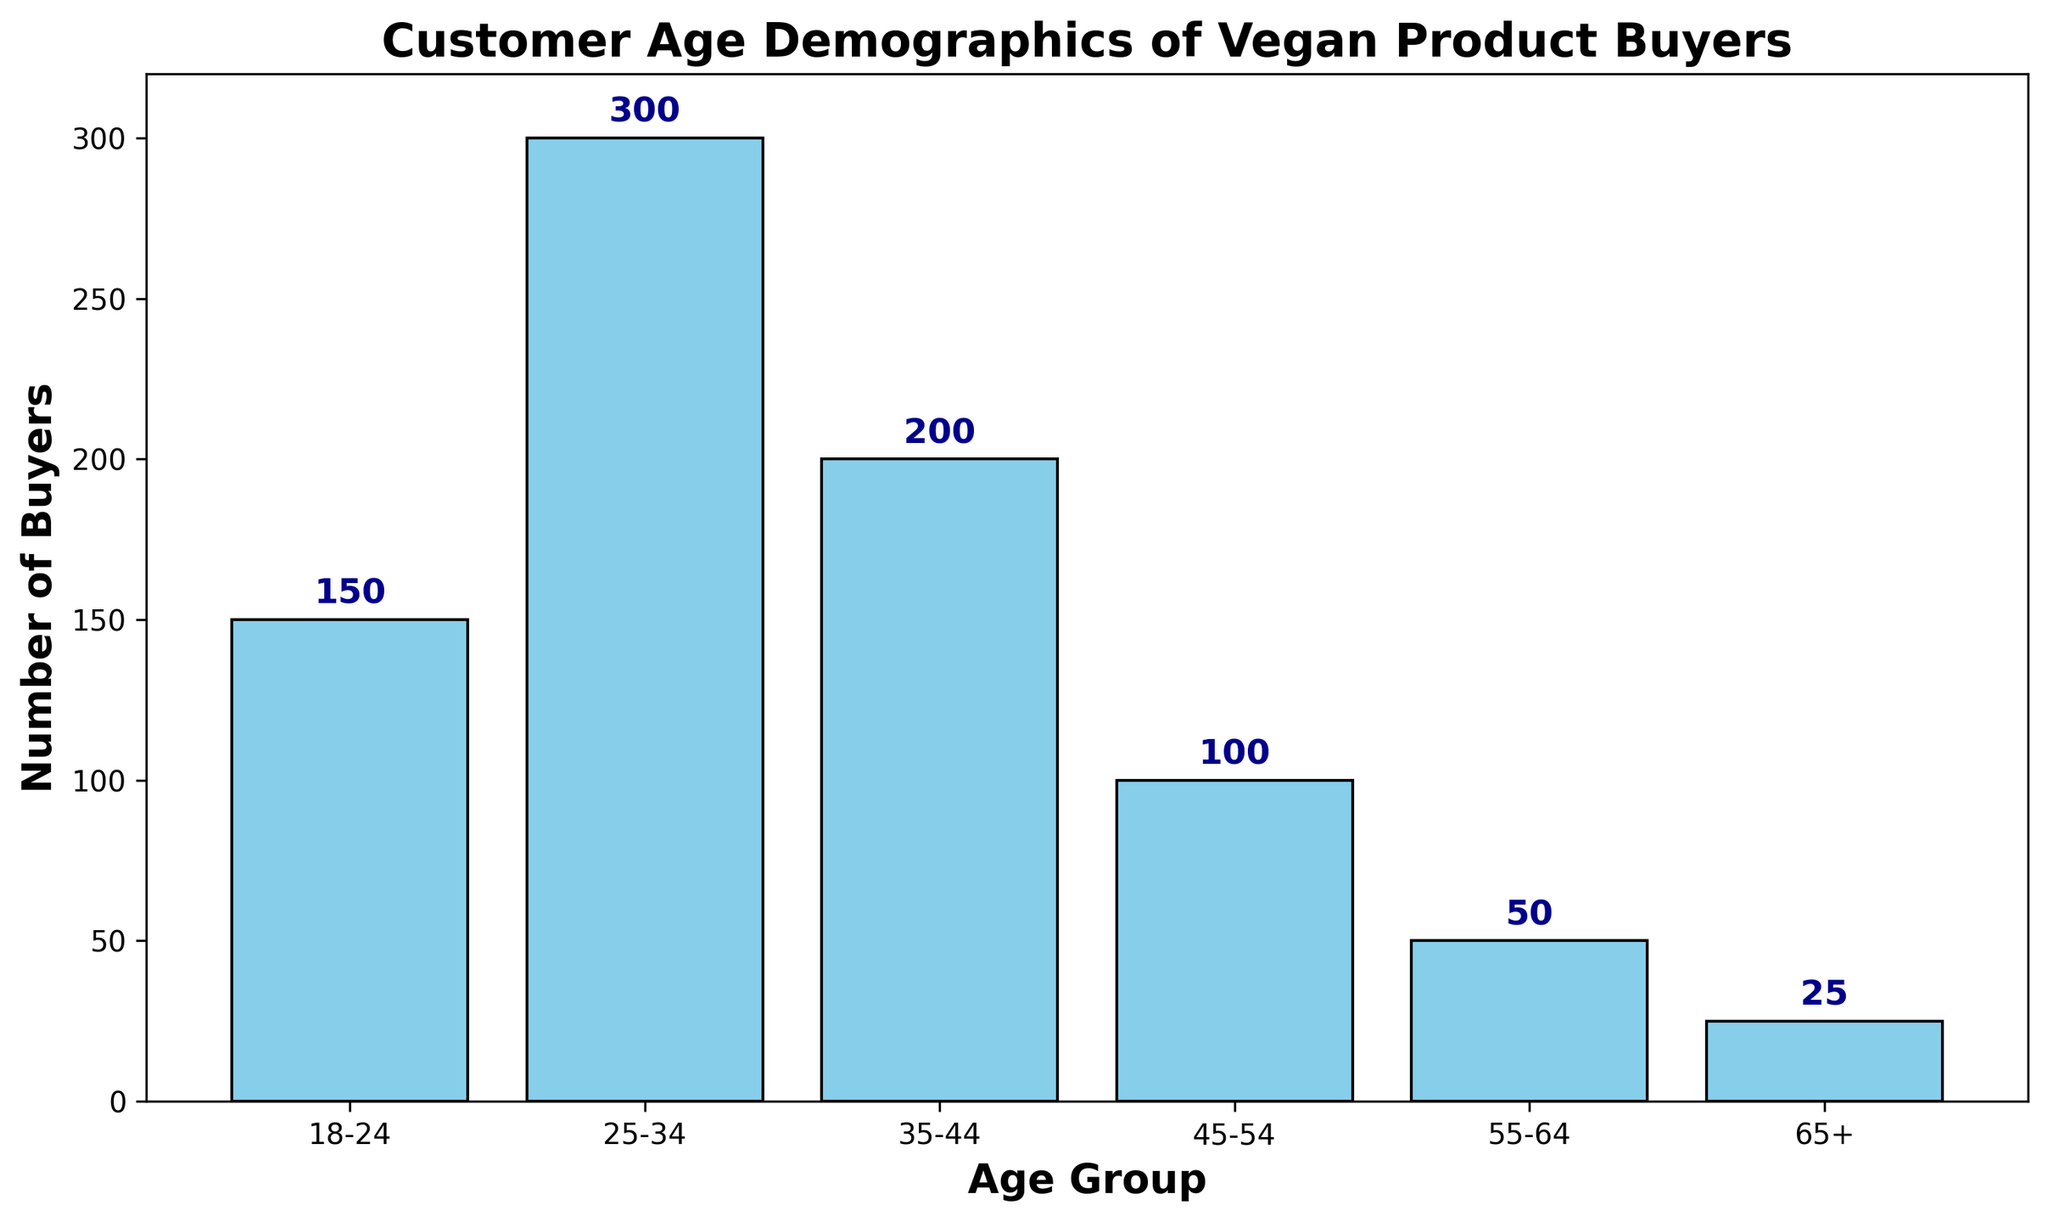What is the age group with the most buyers? By observing the height of the bars, the tallest bar represents the age group with the most buyers. The age group '25-34' has the highest bar.
Answer: 25-34 Which age group has the fewest buyers? The shortest bar on the chart represents the age group with the fewest buyers. The age group '65+' has the shortest bar.
Answer: 65+ How many more buyers are there in the '25-34' age group compared to the '55-64' age group? Subtract the number of buyers in the '55-64' group from the number of buyers in the '25-34' group: 300 - 50 = 250.
Answer: 250 What is the total number of buyers in the age groups '18-24', '25-34', and '35-44'? Add the number of buyers from each of these age groups: 150 (18-24) + 300 (25-34) + 200 (35-44) = 650.
Answer: 650 What is the average number of buyers across all age groups? Sum the numbers of buyers for all age groups and divide by the number of groups: (150 + 300 + 200 + 100 + 50 + 25) / 6 = 825 / 6 ≈ 137.5.
Answer: 137.5 Which age group has twice as many buyers as the '45-54' age group? The '45-54' age group has 100 buyers. The age group with twice as many buyers (2 * 100 = 200) is '35-44'.
Answer: 35-44 What is the difference in the number of buyers between the youngest and oldest age groups? Subtract the number of buyers in the '65+' age group from the number of buyers in the '18-24' age group: 150 - 25 = 125.
Answer: 125 Which age groups have more than 100 buyers? By checking the heights of the bars, the age groups '18-24', '25-34', and '35-44' all have more than 100 buyers.
Answer: 18-24, 25-34, 35-44 What is the combined number of buyers in the '45-54' and '55-64' age groups? Add the number of buyers from these age groups: 100 (45-54) + 50 (55-64) = 150.
Answer: 150 